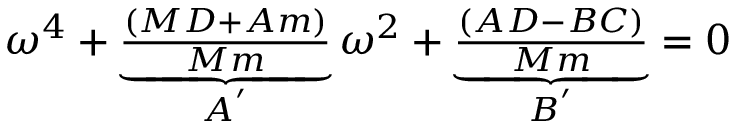Convert formula to latex. <formula><loc_0><loc_0><loc_500><loc_500>\begin{array} { r } { \omega ^ { 4 } + \underbrace { \frac { ( M D + A m ) } { M m } } _ { A ^ { ^ { \prime } } } \omega ^ { 2 } + \underbrace { \frac { ( A D - B C ) } { M m } } _ { B ^ { ^ { \prime } } } = 0 } \end{array}</formula> 